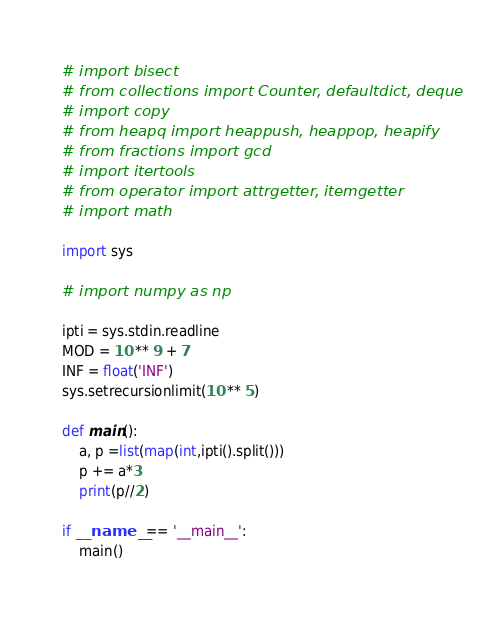<code> <loc_0><loc_0><loc_500><loc_500><_Python_># import bisect
# from collections import Counter, defaultdict, deque
# import copy
# from heapq import heappush, heappop, heapify
# from fractions import gcd
# import itertools
# from operator import attrgetter, itemgetter
# import math

import sys

# import numpy as np

ipti = sys.stdin.readline
MOD = 10 ** 9 + 7
INF = float('INF')
sys.setrecursionlimit(10 ** 5)

def main():
    a, p =list(map(int,ipti().split()))
    p += a*3
    print(p//2)

if __name__ == '__main__':
    main()</code> 